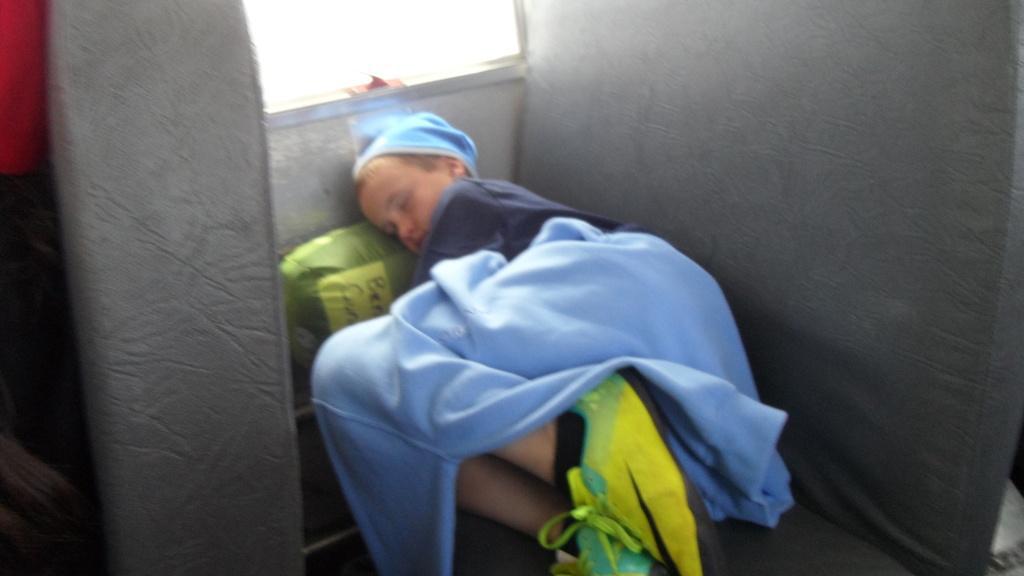In one or two sentences, can you explain what this image depicts? There is one kid lying on a seat as we can see in the middle of this image. There is one another seat on the left side of this image, and it seems like there is a window at the top of this image. 